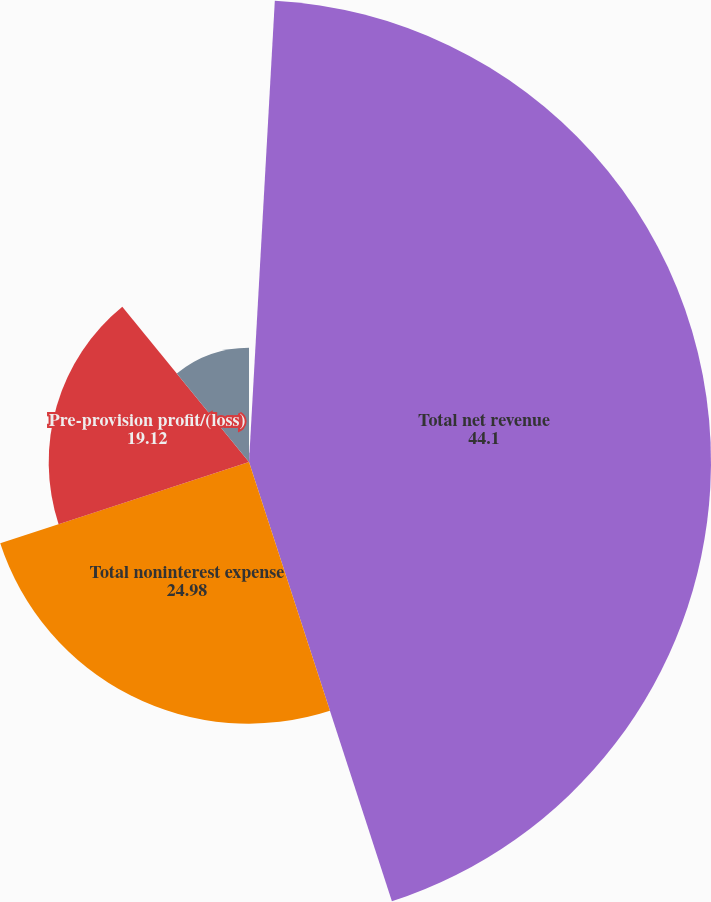Convert chart. <chart><loc_0><loc_0><loc_500><loc_500><pie_chart><fcel>(in millions except ratios)<fcel>Total net revenue<fcel>Total noninterest expense<fcel>Pre-provision profit/(loss)<fcel>Net income/(loss)<nl><fcel>0.89%<fcel>44.1%<fcel>24.98%<fcel>19.12%<fcel>10.9%<nl></chart> 